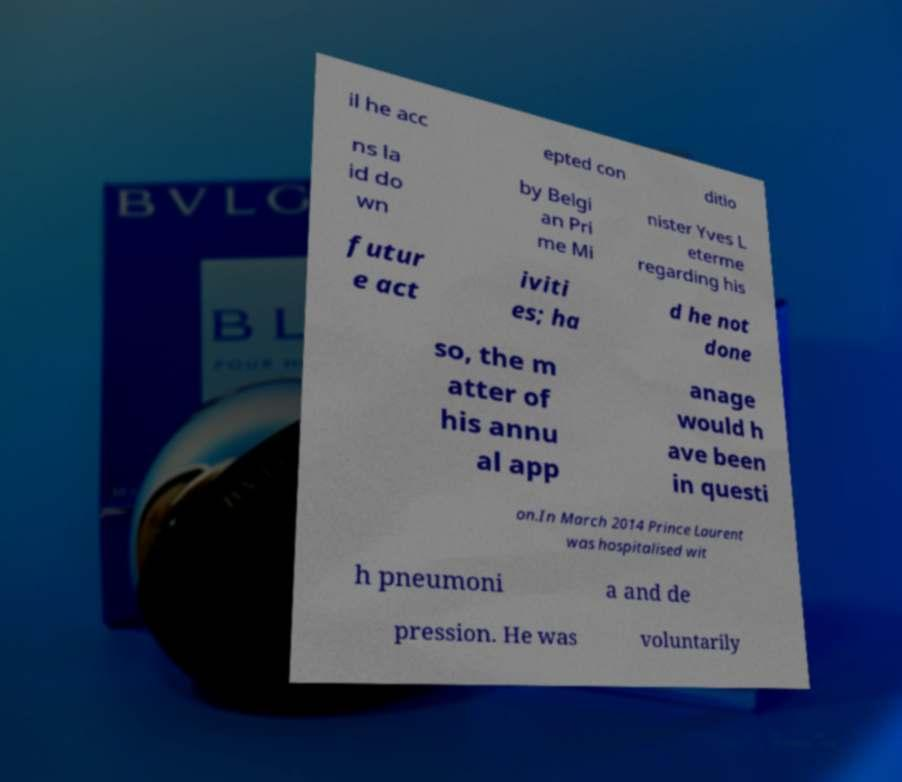I need the written content from this picture converted into text. Can you do that? il he acc epted con ditio ns la id do wn by Belgi an Pri me Mi nister Yves L eterme regarding his futur e act iviti es; ha d he not done so, the m atter of his annu al app anage would h ave been in questi on.In March 2014 Prince Laurent was hospitalised wit h pneumoni a and de pression. He was voluntarily 